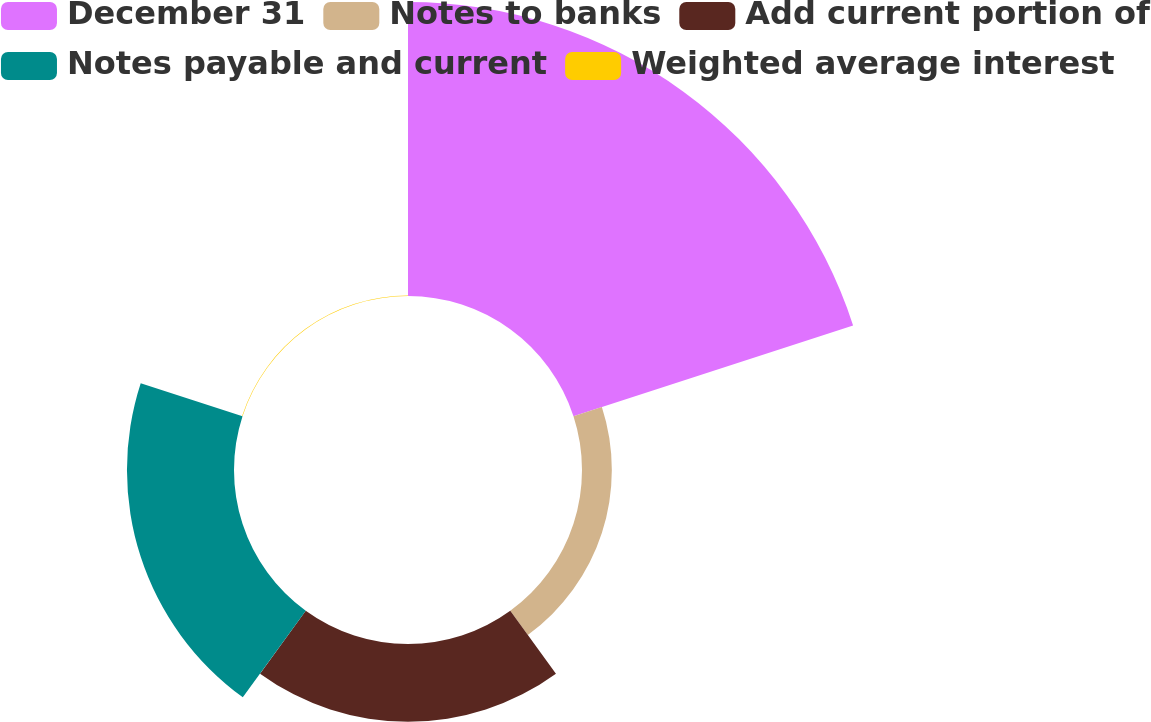<chart> <loc_0><loc_0><loc_500><loc_500><pie_chart><fcel>December 31<fcel>Notes to banks<fcel>Add current portion of<fcel>Notes payable and current<fcel>Weighted average interest<nl><fcel>57.76%<fcel>5.86%<fcel>15.27%<fcel>21.03%<fcel>0.09%<nl></chart> 